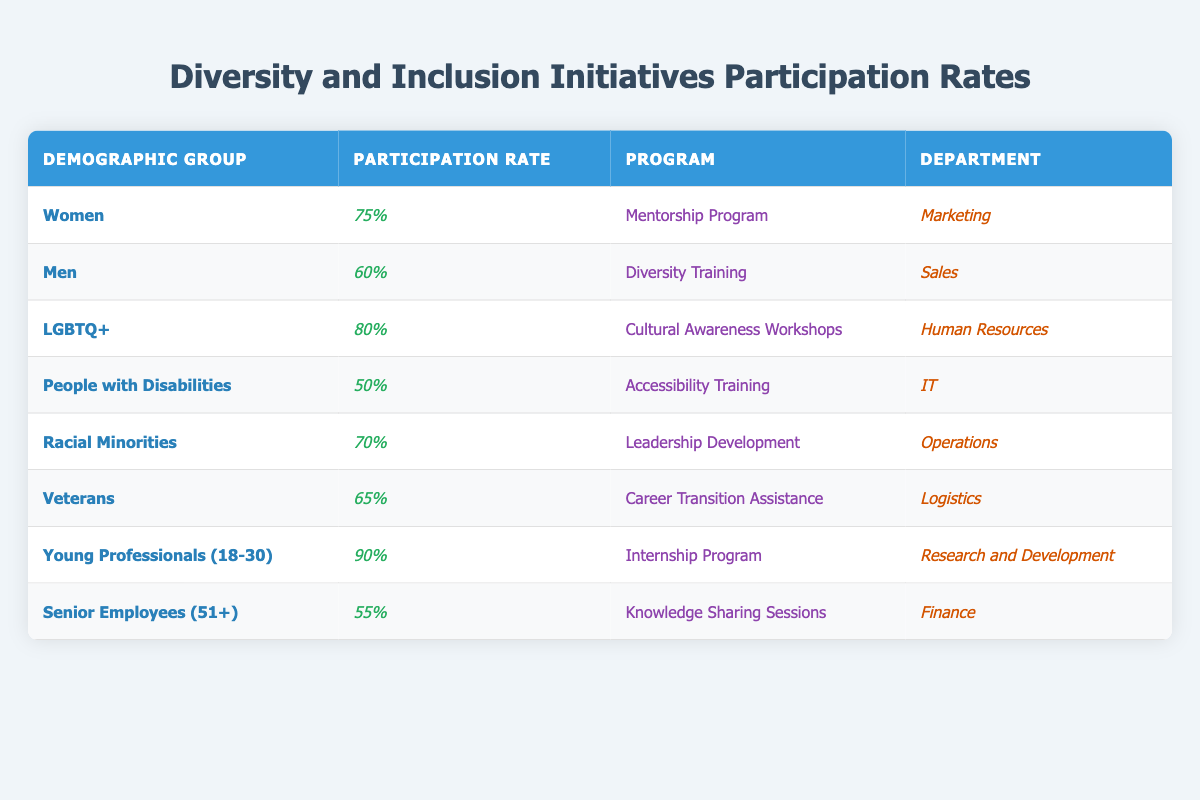What is the participation rate for Women in the Mentorship Program? The table shows that the participation rate for Women in the Mentorship Program is listed under the "Participation Rate" column next to "Women," which is 75%.
Answer: 75% What program has the highest participation rate? By scanning the "Participation Rate" column, the highest value is 90%, which corresponds to the "Internship Program" for "Young Professionals (18-30)."
Answer: Internship Program Is the participation rate for LGBTQ+ higher than that for Veterans? The participation rate for LGBTQ+ is 80%, while for Veterans it is 65%. Since 80% is greater than 65%, the statement is true.
Answer: Yes What is the average participation rate for all demographic groups in the table? Adding the participation rates: 75 + 60 + 80 + 50 + 70 + 65 + 90 + 55 = 600. There are 8 groups, so the average is 600 / 8 = 75%.
Answer: 75% Which department has the lowest participation rate and what is that rate? Scanning the "Participation Rate" column reveals that "People with Disabilities" in the IT department has the lowest rate at 50%.
Answer: IT department, 50% Are the participation rates for Senior Employees and People with Disabilities both below 60%? Senior Employees have a 55% rate and People with Disabilities have a 50% rate. Since both values are below 60%, the statement is true.
Answer: Yes What is the difference in participation rates between Young Professionals and Senior Employees? Young Professionals have a rate of 90%, while Senior Employees have a rate of 55%. The difference is 90% - 55% = 35%.
Answer: 35% How many demographic groups have participation rates of 70% or higher? The rates of 75%, 80%, 70%, and 90% correspond to 4 demographic groups: Women, LGBTQ+, Racial Minorities, and Young Professionals.
Answer: 4 Which demographic group has the highest participation in a program related to training? In the table, "Diversity Training" for "Men" has a 60% participation rate, while "Accessibility Training" for "People with Disabilities" has 50%. The highest is 60%.
Answer: Men, 60% Is there a demographic group with a participation rate of exactly 65%? Yes, the table shows that "Veterans" have a participation rate of 65%.
Answer: Yes 